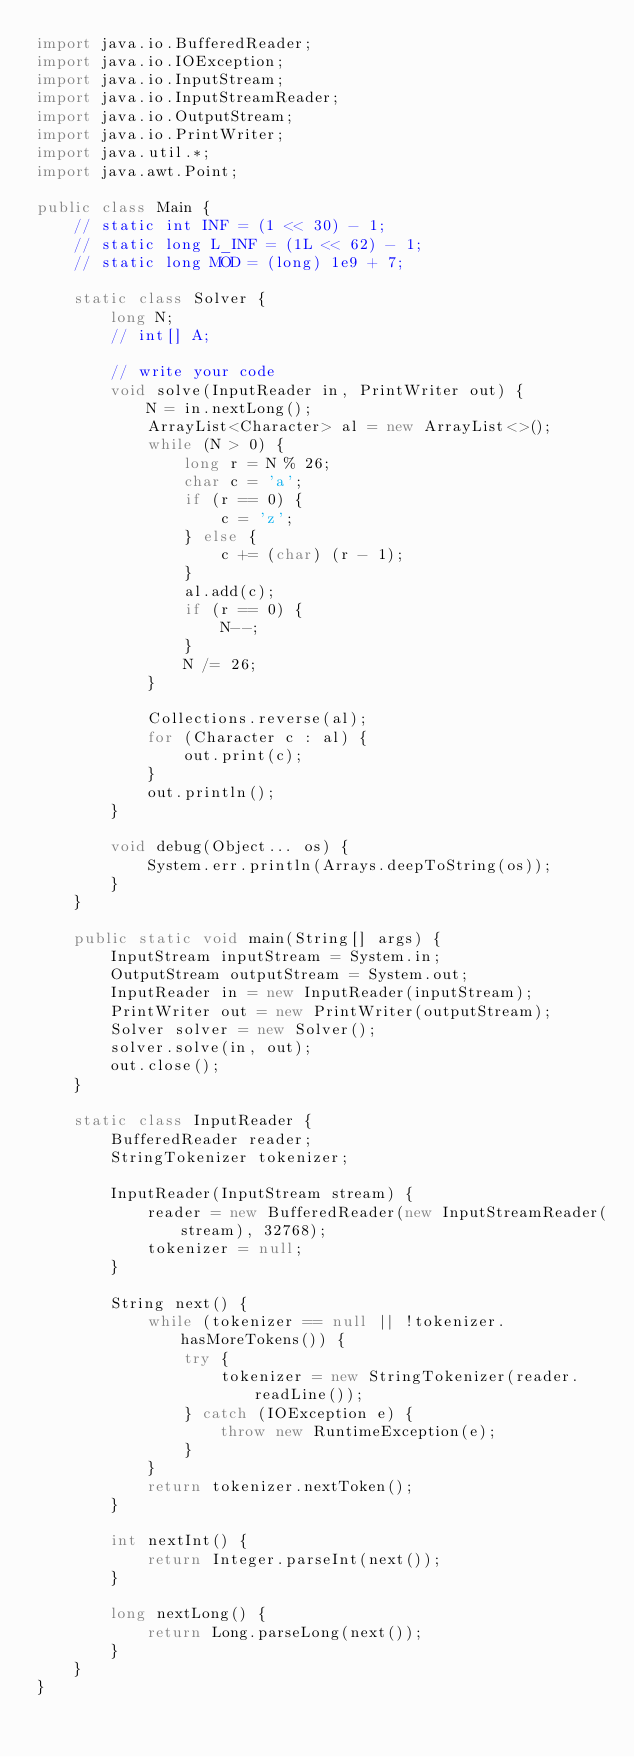Convert code to text. <code><loc_0><loc_0><loc_500><loc_500><_Java_>import java.io.BufferedReader;
import java.io.IOException;
import java.io.InputStream;
import java.io.InputStreamReader;
import java.io.OutputStream;
import java.io.PrintWriter;
import java.util.*;
import java.awt.Point;

public class Main {
    // static int INF = (1 << 30) - 1;
    // static long L_INF = (1L << 62) - 1;
    // static long MOD = (long) 1e9 + 7;

    static class Solver {
        long N;
        // int[] A;

        // write your code
        void solve(InputReader in, PrintWriter out) {
            N = in.nextLong();
            ArrayList<Character> al = new ArrayList<>();
            while (N > 0) {
                long r = N % 26;
                char c = 'a';
                if (r == 0) {
                    c = 'z';
                } else {
                    c += (char) (r - 1);
                }
                al.add(c);
                if (r == 0) {
                    N--;
                }
                N /= 26;
            }

            Collections.reverse(al);
            for (Character c : al) {
                out.print(c);
            }
            out.println();
        }

        void debug(Object... os) {
            System.err.println(Arrays.deepToString(os));
        }
    }

    public static void main(String[] args) {
        InputStream inputStream = System.in;
        OutputStream outputStream = System.out;
        InputReader in = new InputReader(inputStream);
        PrintWriter out = new PrintWriter(outputStream);
        Solver solver = new Solver();
        solver.solve(in, out);
        out.close();
    }

    static class InputReader {
        BufferedReader reader;
        StringTokenizer tokenizer;

        InputReader(InputStream stream) {
            reader = new BufferedReader(new InputStreamReader(stream), 32768);
            tokenizer = null;
        }

        String next() {
            while (tokenizer == null || !tokenizer.hasMoreTokens()) {
                try {
                    tokenizer = new StringTokenizer(reader.readLine());
                } catch (IOException e) {
                    throw new RuntimeException(e);
                }
            }
            return tokenizer.nextToken();
        }

        int nextInt() {
            return Integer.parseInt(next());
        }

        long nextLong() {
            return Long.parseLong(next());
        }
    }
}
</code> 